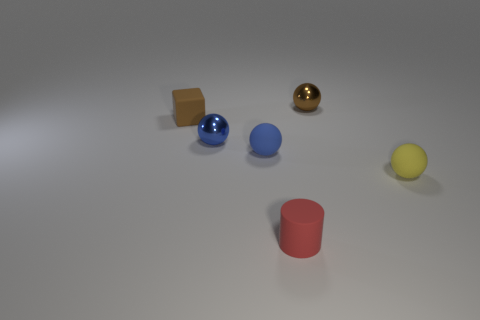Subtract 1 balls. How many balls are left? 3 Subtract all blue rubber balls. How many balls are left? 3 Subtract all red balls. Subtract all blue cylinders. How many balls are left? 4 Add 3 tiny blue metallic balls. How many objects exist? 9 Subtract all cubes. How many objects are left? 5 Add 6 cylinders. How many cylinders exist? 7 Subtract 0 gray cylinders. How many objects are left? 6 Subtract all rubber objects. Subtract all tiny brown metallic cylinders. How many objects are left? 2 Add 2 small brown objects. How many small brown objects are left? 4 